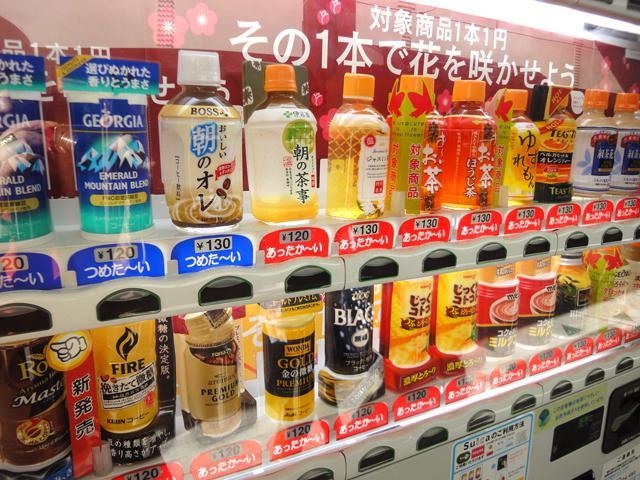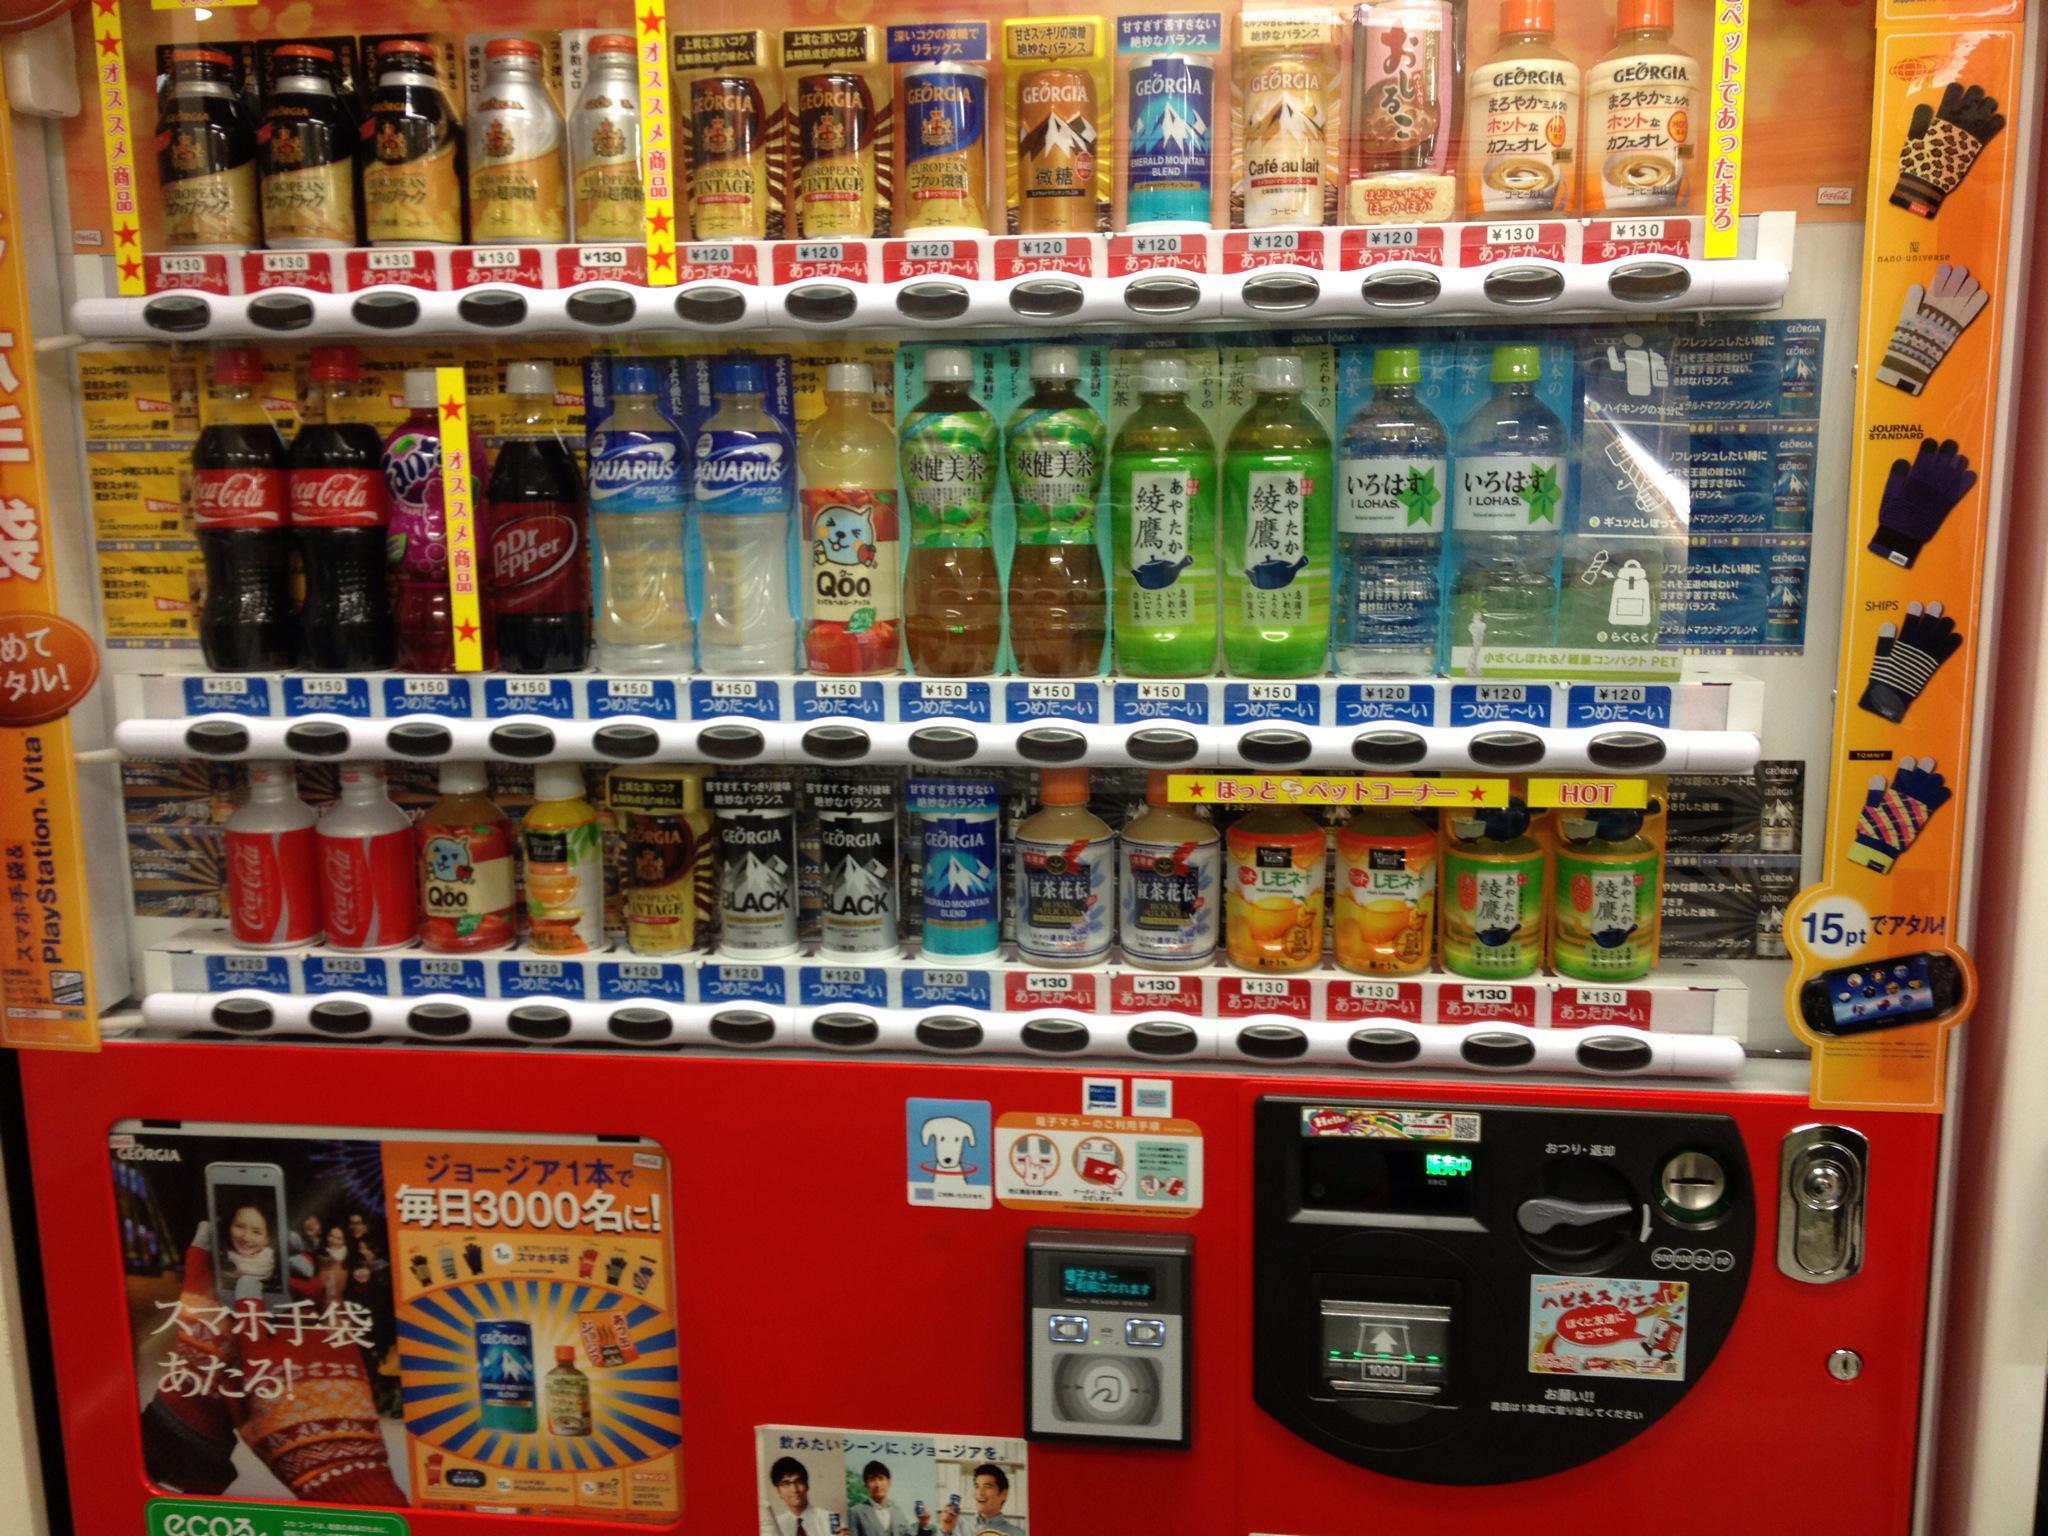The first image is the image on the left, the second image is the image on the right. For the images displayed, is the sentence "An image shows the front of one vending machine, which is red and displays three rows of items." factually correct? Answer yes or no. Yes. The first image is the image on the left, the second image is the image on the right. Evaluate the accuracy of this statement regarding the images: "The image on the left features more than one vending machine.". Is it true? Answer yes or no. No. 